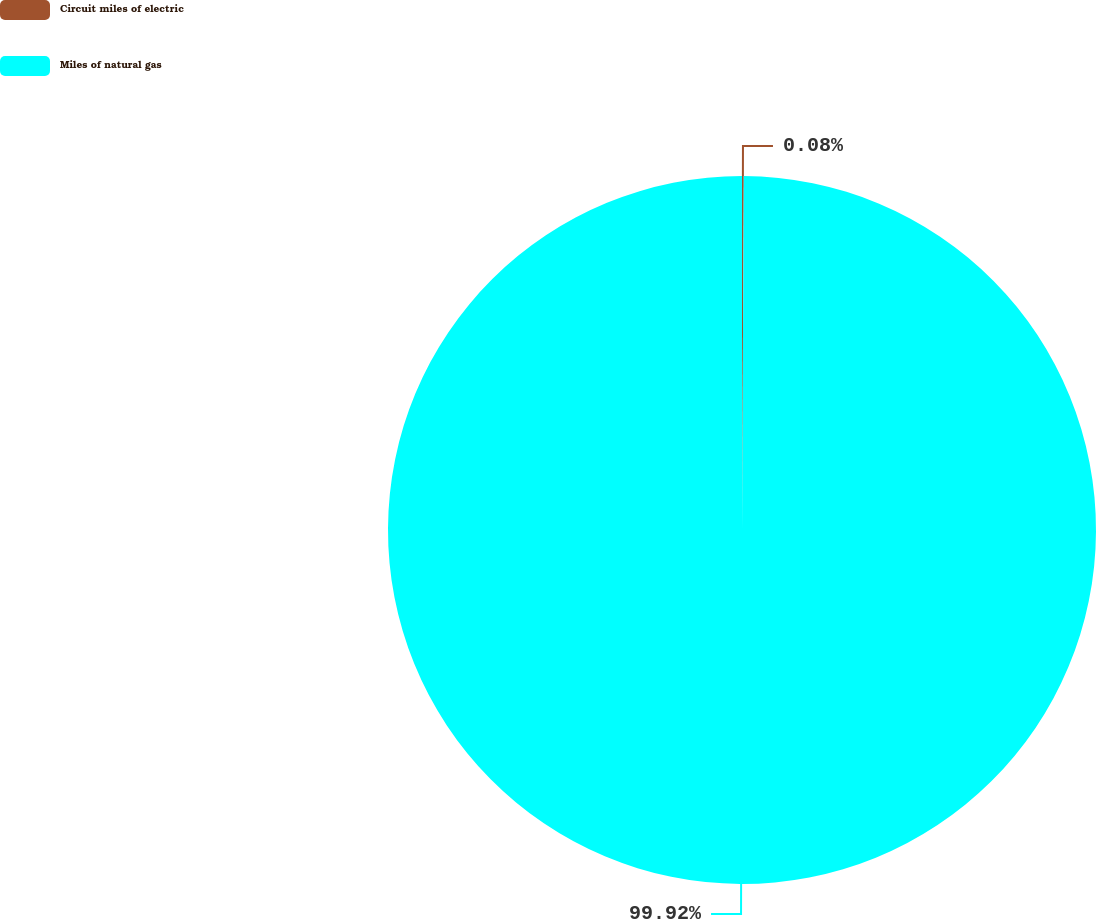Convert chart. <chart><loc_0><loc_0><loc_500><loc_500><pie_chart><fcel>Circuit miles of electric<fcel>Miles of natural gas<nl><fcel>0.08%<fcel>99.92%<nl></chart> 